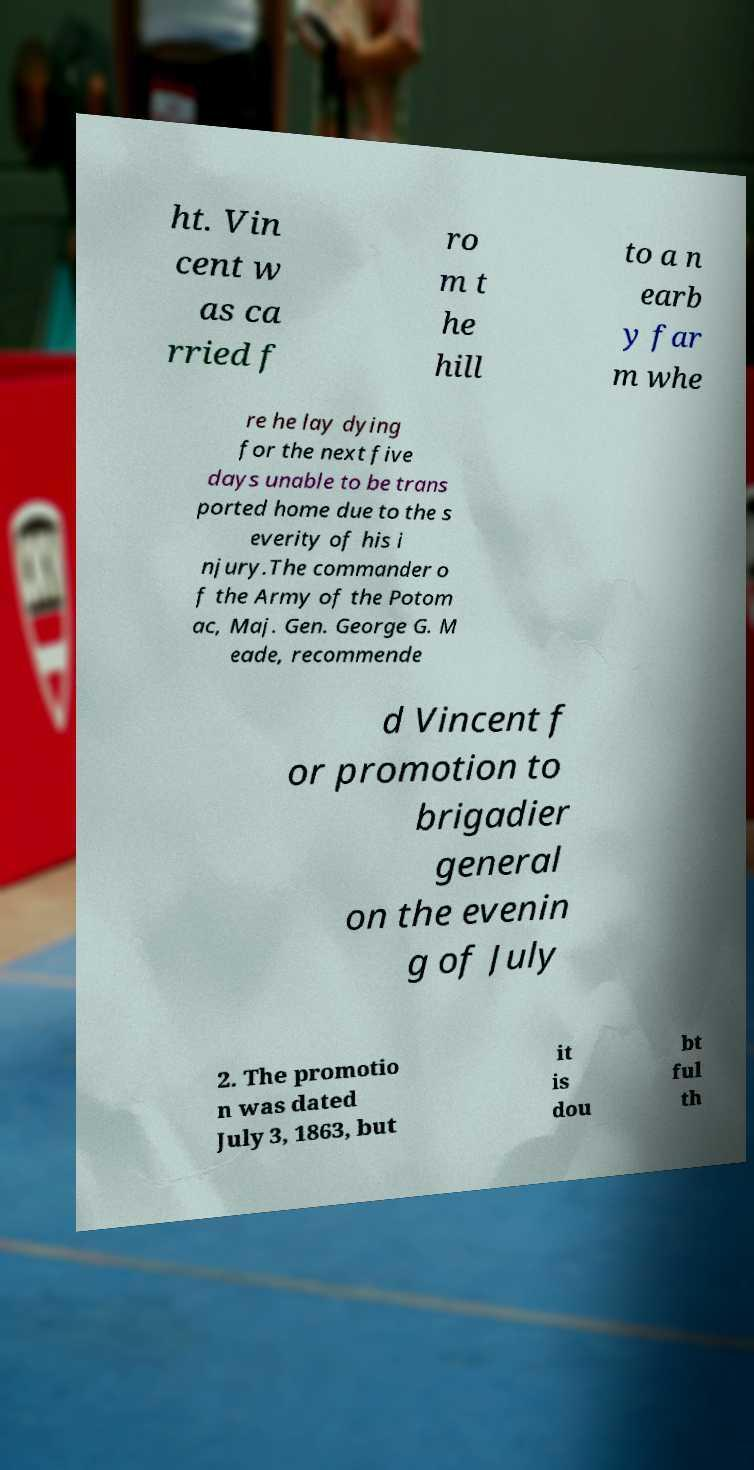Can you read and provide the text displayed in the image?This photo seems to have some interesting text. Can you extract and type it out for me? ht. Vin cent w as ca rried f ro m t he hill to a n earb y far m whe re he lay dying for the next five days unable to be trans ported home due to the s everity of his i njury.The commander o f the Army of the Potom ac, Maj. Gen. George G. M eade, recommende d Vincent f or promotion to brigadier general on the evenin g of July 2. The promotio n was dated July 3, 1863, but it is dou bt ful th 